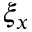Convert formula to latex. <formula><loc_0><loc_0><loc_500><loc_500>\xi _ { x }</formula> 